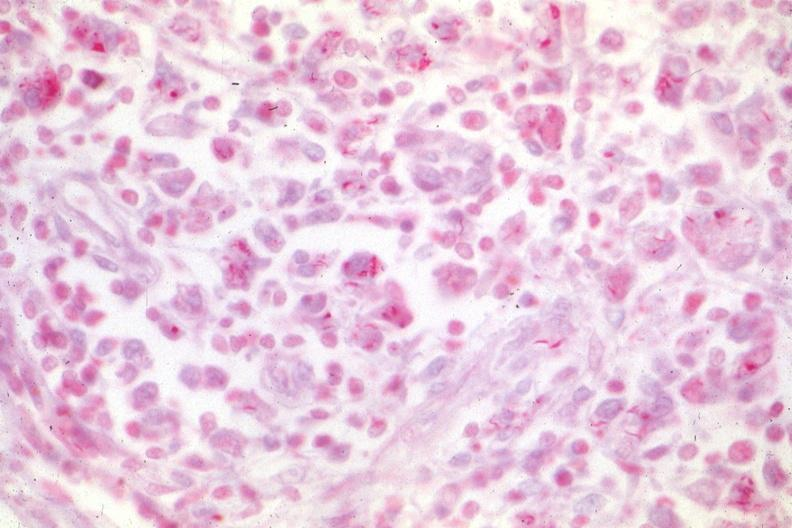what is present?
Answer the question using a single word or phrase. Lymph node 